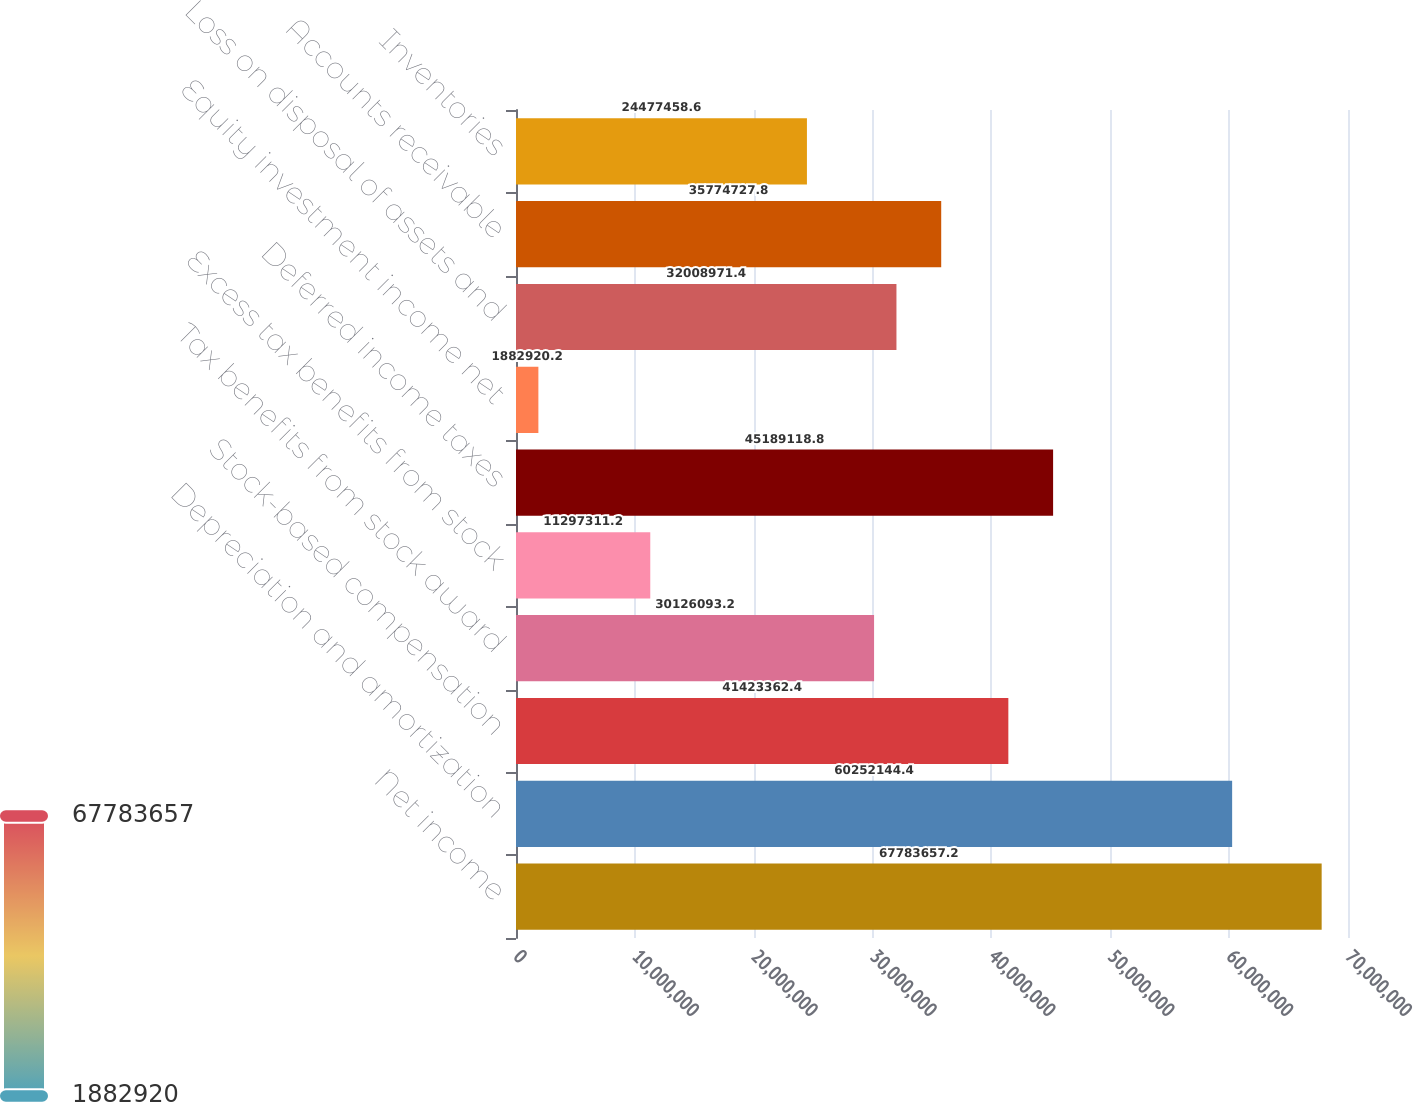Convert chart to OTSL. <chart><loc_0><loc_0><loc_500><loc_500><bar_chart><fcel>Net income<fcel>Depreciation and amortization<fcel>Stock-based compensation<fcel>Tax benefits from stock award<fcel>Excess tax benefits from stock<fcel>Deferred income taxes<fcel>Equity investment income net<fcel>Loss on disposal of assets and<fcel>Accounts receivable<fcel>Inventories<nl><fcel>6.77837e+07<fcel>6.02521e+07<fcel>4.14234e+07<fcel>3.01261e+07<fcel>1.12973e+07<fcel>4.51891e+07<fcel>1.88292e+06<fcel>3.2009e+07<fcel>3.57747e+07<fcel>2.44775e+07<nl></chart> 